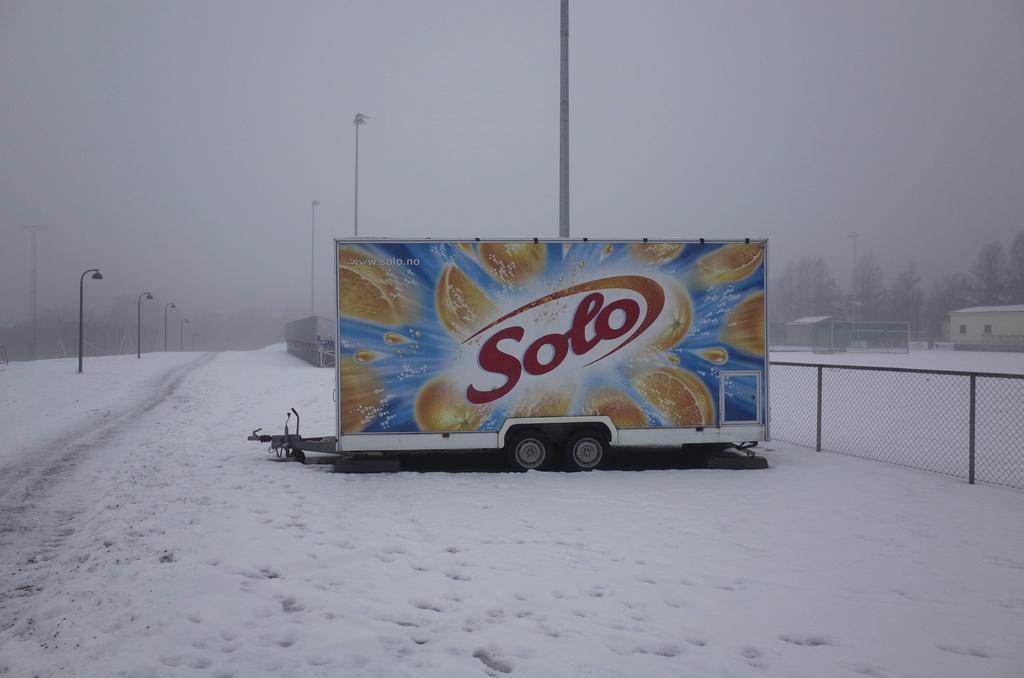Describe this image in one or two sentences. In this picture there is a poster in the center of the image, on a vehicle and there are houses, trees, and poles in the background area of the image, which are covered with snow and there is snow around the area of the image. 